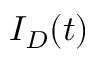Convert formula to latex. <formula><loc_0><loc_0><loc_500><loc_500>I _ { D } ( t )</formula> 